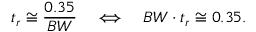<formula> <loc_0><loc_0><loc_500><loc_500>t _ { r } \cong { \frac { 0 . 3 5 } { B W } } \quad \Longleftrightarrow \quad B W \cdot t _ { r } \cong 0 . 3 5 .</formula> 